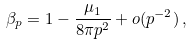Convert formula to latex. <formula><loc_0><loc_0><loc_500><loc_500>\beta _ { p } = 1 - \frac { \mu _ { 1 } } { 8 \pi p ^ { 2 } } + o ( p ^ { - 2 } ) \, ,</formula> 